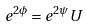Convert formula to latex. <formula><loc_0><loc_0><loc_500><loc_500>e ^ { 2 \phi } = e ^ { 2 \psi } U</formula> 